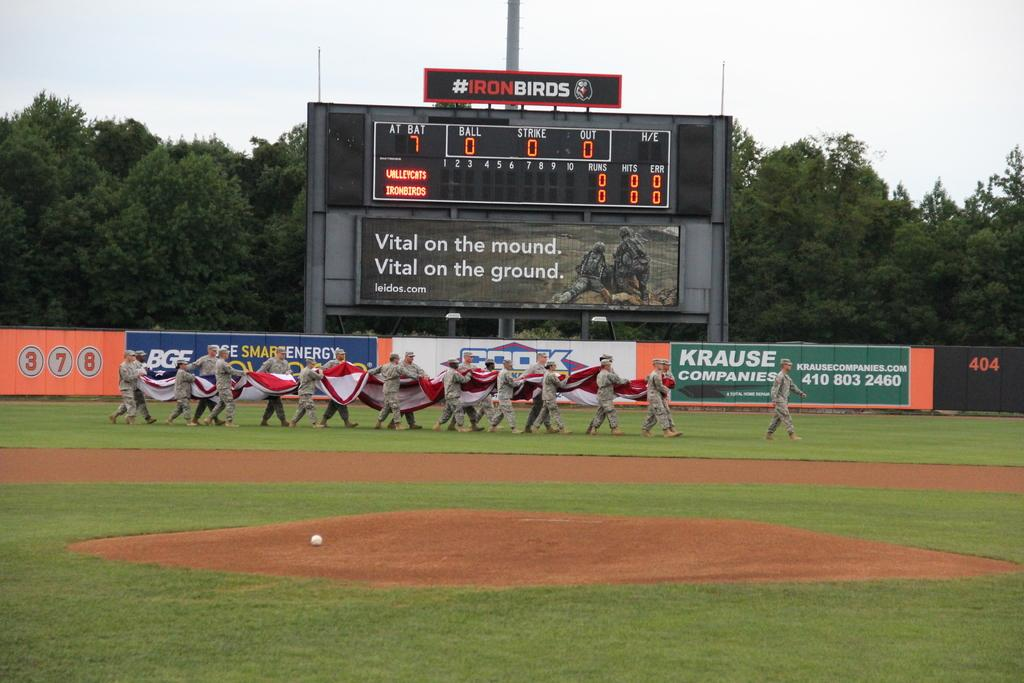<image>
Present a compact description of the photo's key features. some people on a baseball field with a krause sign 